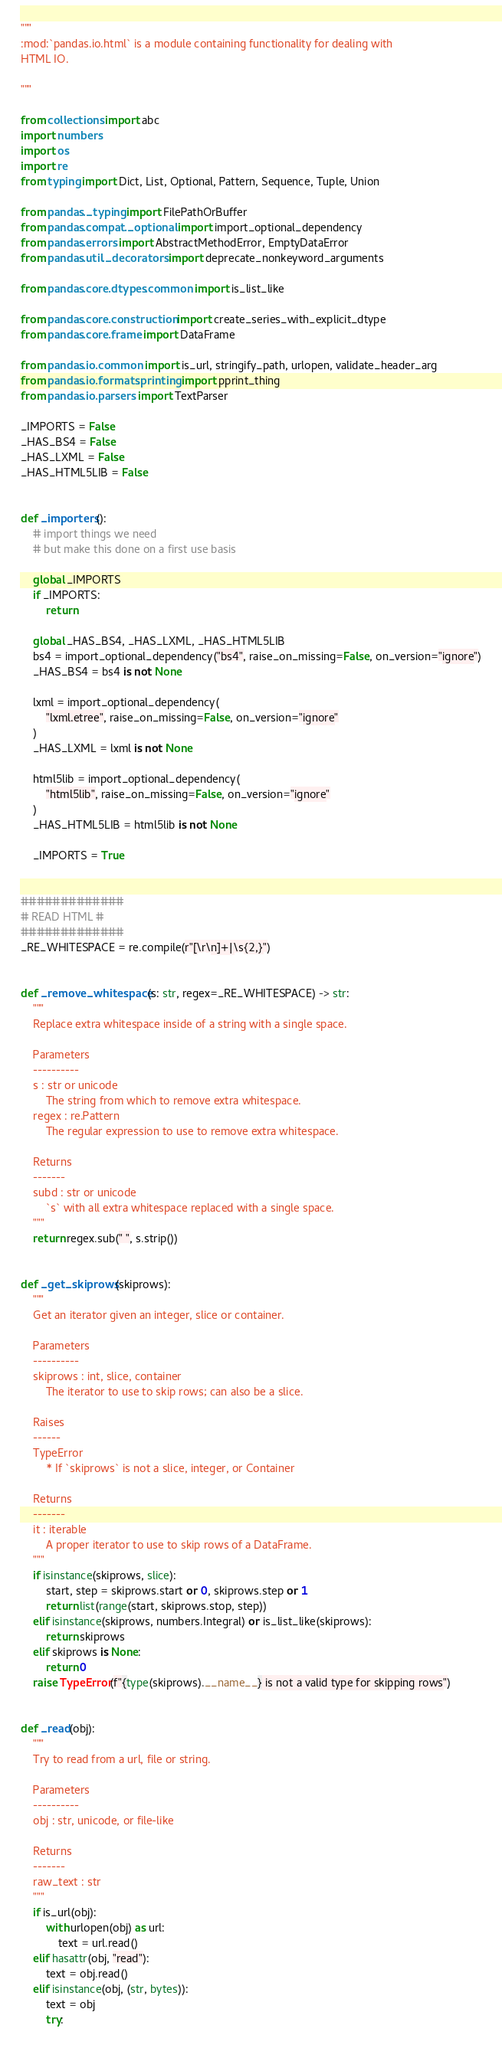Convert code to text. <code><loc_0><loc_0><loc_500><loc_500><_Python_>"""
:mod:`pandas.io.html` is a module containing functionality for dealing with
HTML IO.

"""

from collections import abc
import numbers
import os
import re
from typing import Dict, List, Optional, Pattern, Sequence, Tuple, Union

from pandas._typing import FilePathOrBuffer
from pandas.compat._optional import import_optional_dependency
from pandas.errors import AbstractMethodError, EmptyDataError
from pandas.util._decorators import deprecate_nonkeyword_arguments

from pandas.core.dtypes.common import is_list_like

from pandas.core.construction import create_series_with_explicit_dtype
from pandas.core.frame import DataFrame

from pandas.io.common import is_url, stringify_path, urlopen, validate_header_arg
from pandas.io.formats.printing import pprint_thing
from pandas.io.parsers import TextParser

_IMPORTS = False
_HAS_BS4 = False
_HAS_LXML = False
_HAS_HTML5LIB = False


def _importers():
    # import things we need
    # but make this done on a first use basis

    global _IMPORTS
    if _IMPORTS:
        return

    global _HAS_BS4, _HAS_LXML, _HAS_HTML5LIB
    bs4 = import_optional_dependency("bs4", raise_on_missing=False, on_version="ignore")
    _HAS_BS4 = bs4 is not None

    lxml = import_optional_dependency(
        "lxml.etree", raise_on_missing=False, on_version="ignore"
    )
    _HAS_LXML = lxml is not None

    html5lib = import_optional_dependency(
        "html5lib", raise_on_missing=False, on_version="ignore"
    )
    _HAS_HTML5LIB = html5lib is not None

    _IMPORTS = True


#############
# READ HTML #
#############
_RE_WHITESPACE = re.compile(r"[\r\n]+|\s{2,}")


def _remove_whitespace(s: str, regex=_RE_WHITESPACE) -> str:
    """
    Replace extra whitespace inside of a string with a single space.

    Parameters
    ----------
    s : str or unicode
        The string from which to remove extra whitespace.
    regex : re.Pattern
        The regular expression to use to remove extra whitespace.

    Returns
    -------
    subd : str or unicode
        `s` with all extra whitespace replaced with a single space.
    """
    return regex.sub(" ", s.strip())


def _get_skiprows(skiprows):
    """
    Get an iterator given an integer, slice or container.

    Parameters
    ----------
    skiprows : int, slice, container
        The iterator to use to skip rows; can also be a slice.

    Raises
    ------
    TypeError
        * If `skiprows` is not a slice, integer, or Container

    Returns
    -------
    it : iterable
        A proper iterator to use to skip rows of a DataFrame.
    """
    if isinstance(skiprows, slice):
        start, step = skiprows.start or 0, skiprows.step or 1
        return list(range(start, skiprows.stop, step))
    elif isinstance(skiprows, numbers.Integral) or is_list_like(skiprows):
        return skiprows
    elif skiprows is None:
        return 0
    raise TypeError(f"{type(skiprows).__name__} is not a valid type for skipping rows")


def _read(obj):
    """
    Try to read from a url, file or string.

    Parameters
    ----------
    obj : str, unicode, or file-like

    Returns
    -------
    raw_text : str
    """
    if is_url(obj):
        with urlopen(obj) as url:
            text = url.read()
    elif hasattr(obj, "read"):
        text = obj.read()
    elif isinstance(obj, (str, bytes)):
        text = obj
        try:</code> 